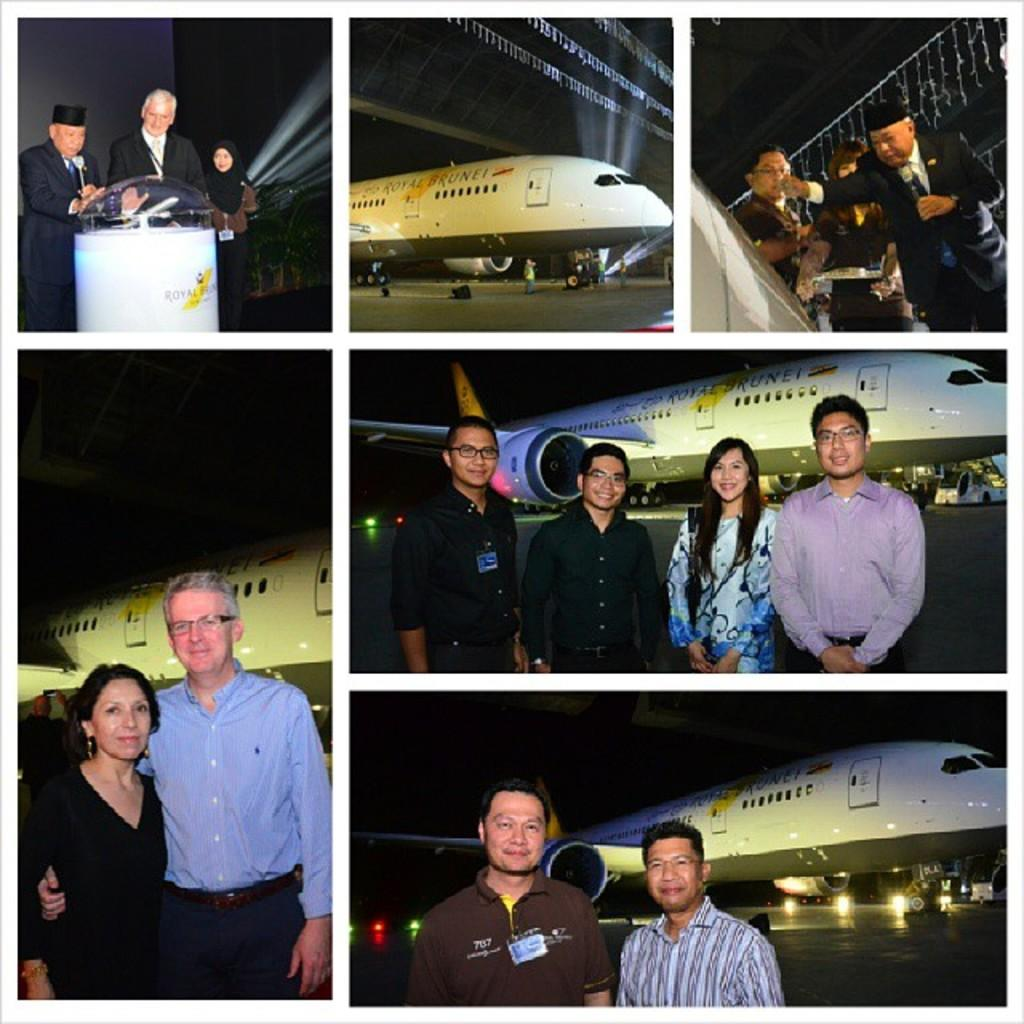What type of image is being described? The image is a collage. What can be seen in the collage? There are people standing and aeroplanes in the image. What type of locket is being worn by the people in the image? There is no mention of a locket in the image, as the facts only mention people standing and aeroplanes. 